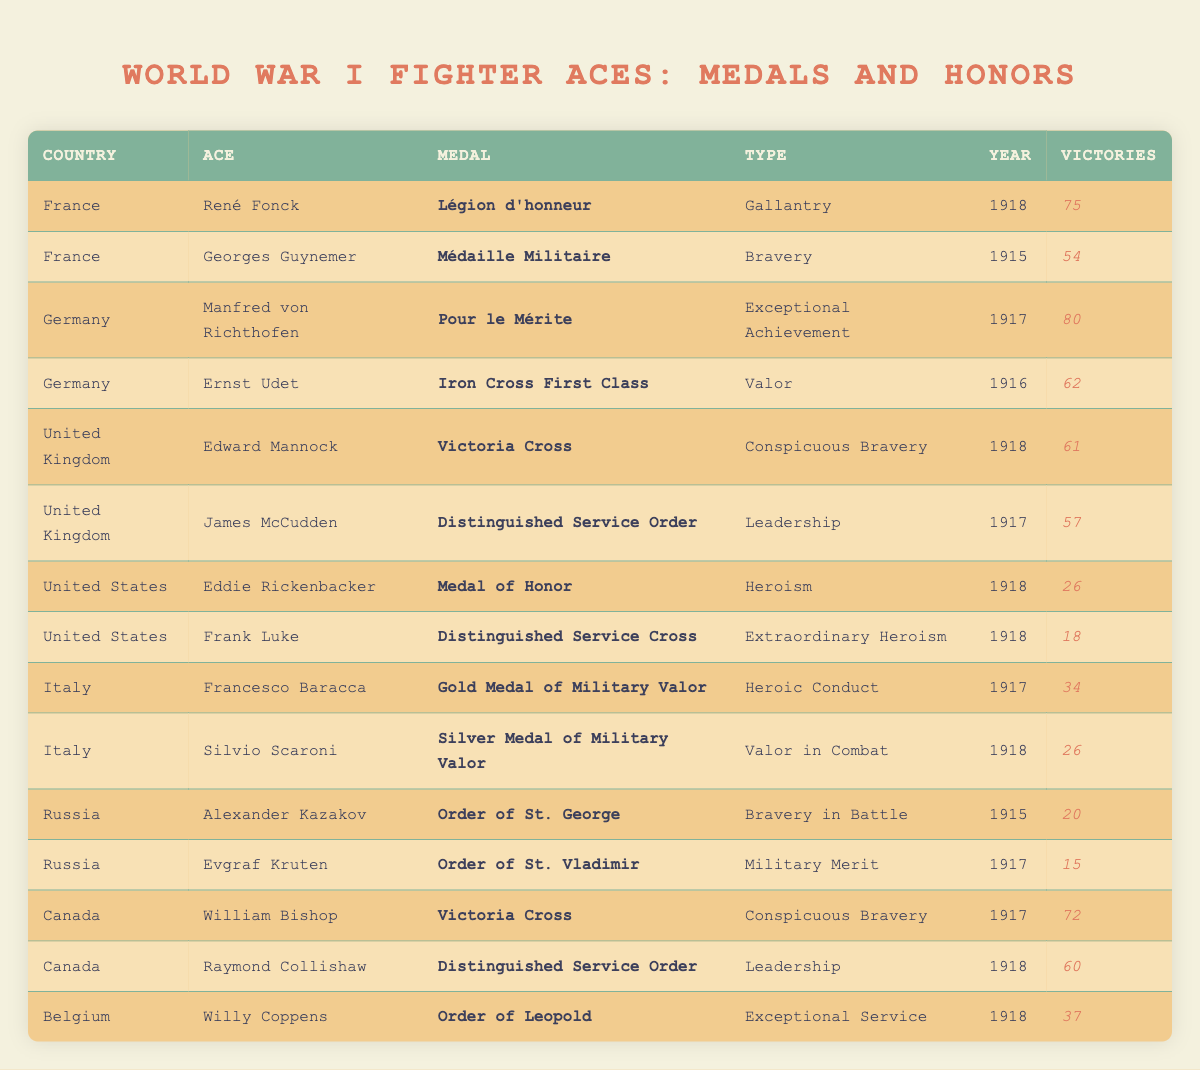What medal did René Fonck receive? According to the table, the medal awarded to René Fonck is the Légion d'honneur.
Answer: Légion d'honneur How many victories did Manfred von Richthofen have? The table shows that Manfred von Richthofen had 80 victories.
Answer: 80 Which country awarded the Victoria Cross to William Bishop? By examining the table, it's clear that Canada awarded the Victoria Cross to William Bishop.
Answer: Canada What is the total number of victories by the aces from Italy? From the table, the victories are 34 (Francesco Baracca) + 26 (Silvio Scaroni) = 60. Thus, the total number of victories by the aces from Italy is 60.
Answer: 60 Did any United States fighter ace receive a medal for heroism? Yes, Eddie Rickenbacker received the Medal of Honor for heroism, as stated in the table.
Answer: Yes Which type of achievement was most common among the awarded medals in the table? The table lists different types of achievements, including valor, bravery, and others. After reviewing, the most common types of achievement appear to be bravery and valor, each occurring multiple times.
Answer: Bravery and Valor Out of the aces listed, who had the least number of victories? The table shows that Evgraf Kruten had the least number of victories with 15.
Answer: 15 What is the average number of victories for the aces from Germany? The victories for German aces are 80 (Manfred von Richthofen) and 62 (Ernst Udet), leading to an average calculated as (80 + 62) / 2 = 71.
Answer: 71 Which fighter ace received the Iron Cross First Class? The table specifies that Ernst Udet received the Iron Cross First Class.
Answer: Ernst Udet 